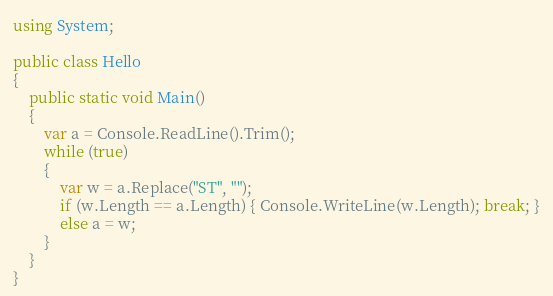Convert code to text. <code><loc_0><loc_0><loc_500><loc_500><_C#_>using System;

public class Hello
{
    public static void Main()
    {
        var a = Console.ReadLine().Trim();
        while (true)
        {
            var w = a.Replace("ST", "");
            if (w.Length == a.Length) { Console.WriteLine(w.Length); break; }
            else a = w;
        }
    }
}
</code> 